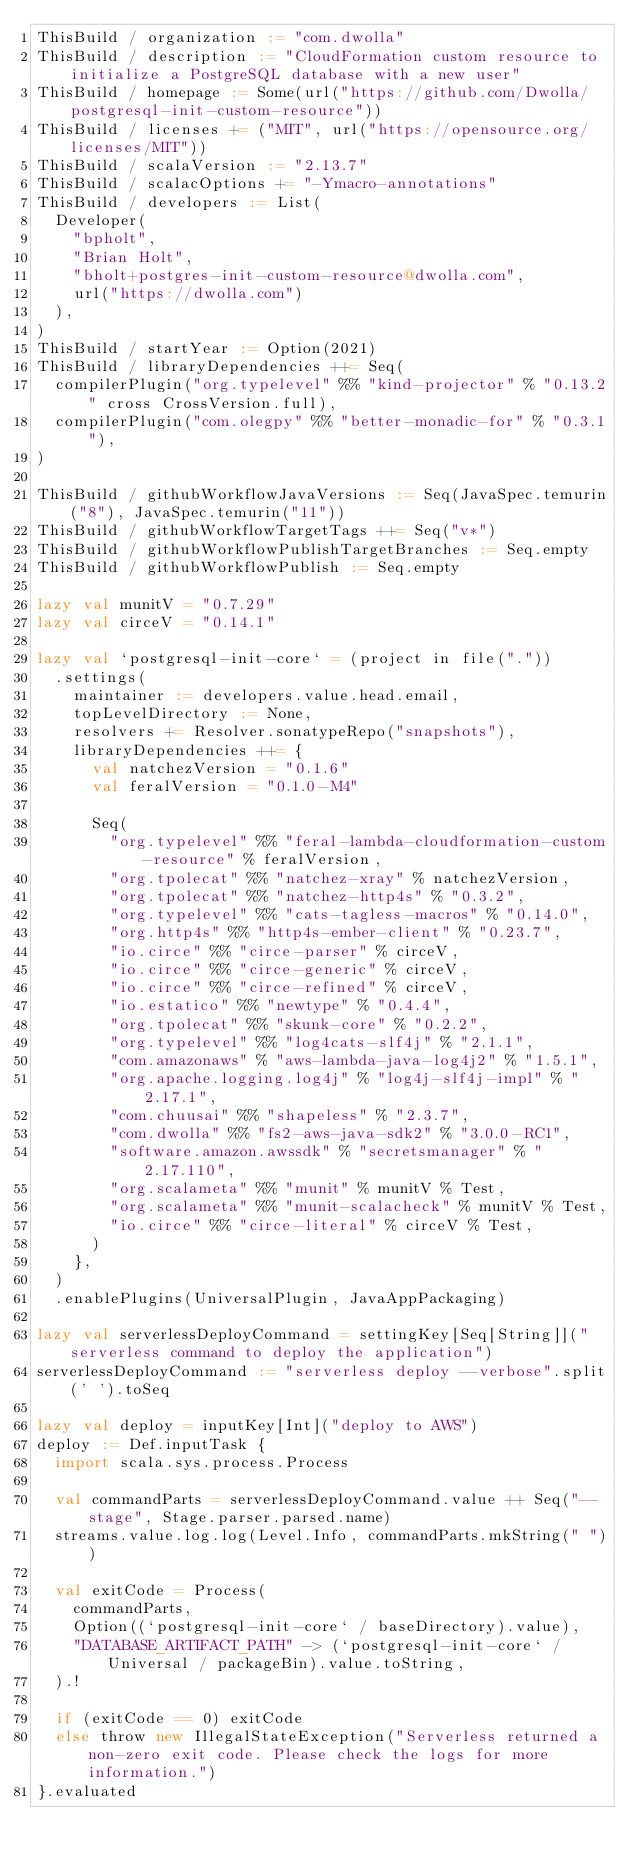<code> <loc_0><loc_0><loc_500><loc_500><_Scala_>ThisBuild / organization := "com.dwolla"
ThisBuild / description := "CloudFormation custom resource to initialize a PostgreSQL database with a new user"
ThisBuild / homepage := Some(url("https://github.com/Dwolla/postgresql-init-custom-resource"))
ThisBuild / licenses += ("MIT", url("https://opensource.org/licenses/MIT"))
ThisBuild / scalaVersion := "2.13.7"
ThisBuild / scalacOptions += "-Ymacro-annotations"
ThisBuild / developers := List(
  Developer(
    "bpholt",
    "Brian Holt",
    "bholt+postgres-init-custom-resource@dwolla.com",
    url("https://dwolla.com")
  ),
)
ThisBuild / startYear := Option(2021)
ThisBuild / libraryDependencies ++= Seq(
  compilerPlugin("org.typelevel" %% "kind-projector" % "0.13.2" cross CrossVersion.full),
  compilerPlugin("com.olegpy" %% "better-monadic-for" % "0.3.1"),
)

ThisBuild / githubWorkflowJavaVersions := Seq(JavaSpec.temurin("8"), JavaSpec.temurin("11"))
ThisBuild / githubWorkflowTargetTags ++= Seq("v*")
ThisBuild / githubWorkflowPublishTargetBranches := Seq.empty
ThisBuild / githubWorkflowPublish := Seq.empty

lazy val munitV = "0.7.29"
lazy val circeV = "0.14.1"

lazy val `postgresql-init-core` = (project in file("."))
  .settings(
    maintainer := developers.value.head.email,
    topLevelDirectory := None,
    resolvers += Resolver.sonatypeRepo("snapshots"),
    libraryDependencies ++= {
      val natchezVersion = "0.1.6"
      val feralVersion = "0.1.0-M4"

      Seq(
        "org.typelevel" %% "feral-lambda-cloudformation-custom-resource" % feralVersion,
        "org.tpolecat" %% "natchez-xray" % natchezVersion,
        "org.tpolecat" %% "natchez-http4s" % "0.3.2",
        "org.typelevel" %% "cats-tagless-macros" % "0.14.0",
        "org.http4s" %% "http4s-ember-client" % "0.23.7",
        "io.circe" %% "circe-parser" % circeV,
        "io.circe" %% "circe-generic" % circeV,
        "io.circe" %% "circe-refined" % circeV,
        "io.estatico" %% "newtype" % "0.4.4",
        "org.tpolecat" %% "skunk-core" % "0.2.2",
        "org.typelevel" %% "log4cats-slf4j" % "2.1.1",
        "com.amazonaws" % "aws-lambda-java-log4j2" % "1.5.1",
        "org.apache.logging.log4j" % "log4j-slf4j-impl" % "2.17.1",
        "com.chuusai" %% "shapeless" % "2.3.7",
        "com.dwolla" %% "fs2-aws-java-sdk2" % "3.0.0-RC1",
        "software.amazon.awssdk" % "secretsmanager" % "2.17.110",
        "org.scalameta" %% "munit" % munitV % Test,
        "org.scalameta" %% "munit-scalacheck" % munitV % Test,
        "io.circe" %% "circe-literal" % circeV % Test,
      )
    },
  )
  .enablePlugins(UniversalPlugin, JavaAppPackaging)

lazy val serverlessDeployCommand = settingKey[Seq[String]]("serverless command to deploy the application")
serverlessDeployCommand := "serverless deploy --verbose".split(' ').toSeq

lazy val deploy = inputKey[Int]("deploy to AWS")
deploy := Def.inputTask {
  import scala.sys.process.Process

  val commandParts = serverlessDeployCommand.value ++ Seq("--stage", Stage.parser.parsed.name)
  streams.value.log.log(Level.Info, commandParts.mkString(" "))

  val exitCode = Process(
    commandParts,
    Option((`postgresql-init-core` / baseDirectory).value),
    "DATABASE_ARTIFACT_PATH" -> (`postgresql-init-core` / Universal / packageBin).value.toString,
  ).!

  if (exitCode == 0) exitCode
  else throw new IllegalStateException("Serverless returned a non-zero exit code. Please check the logs for more information.")
}.evaluated
</code> 